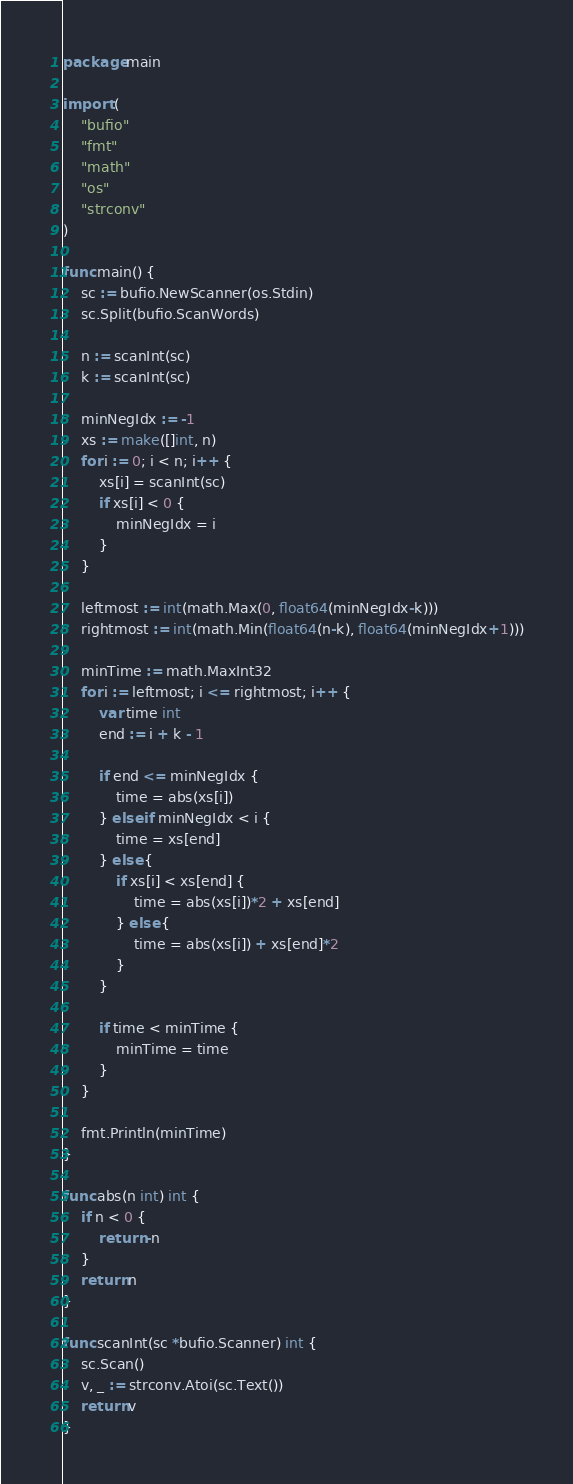Convert code to text. <code><loc_0><loc_0><loc_500><loc_500><_Go_>package main

import (
	"bufio"
	"fmt"
	"math"
	"os"
	"strconv"
)

func main() {
	sc := bufio.NewScanner(os.Stdin)
	sc.Split(bufio.ScanWords)

	n := scanInt(sc)
	k := scanInt(sc)

	minNegIdx := -1
	xs := make([]int, n)
	for i := 0; i < n; i++ {
		xs[i] = scanInt(sc)
		if xs[i] < 0 {
			minNegIdx = i
		}
	}

	leftmost := int(math.Max(0, float64(minNegIdx-k)))
	rightmost := int(math.Min(float64(n-k), float64(minNegIdx+1)))

	minTime := math.MaxInt32
	for i := leftmost; i <= rightmost; i++ {
		var time int
		end := i + k - 1

		if end <= minNegIdx {
			time = abs(xs[i])
		} else if minNegIdx < i {
			time = xs[end]
		} else {
			if xs[i] < xs[end] {
				time = abs(xs[i])*2 + xs[end]
			} else {
				time = abs(xs[i]) + xs[end]*2
			}
		}

		if time < minTime {
			minTime = time
		}
	}

	fmt.Println(minTime)
}

func abs(n int) int {
	if n < 0 {
		return -n
	}
	return n
}

func scanInt(sc *bufio.Scanner) int {
	sc.Scan()
	v, _ := strconv.Atoi(sc.Text())
	return v
}
</code> 